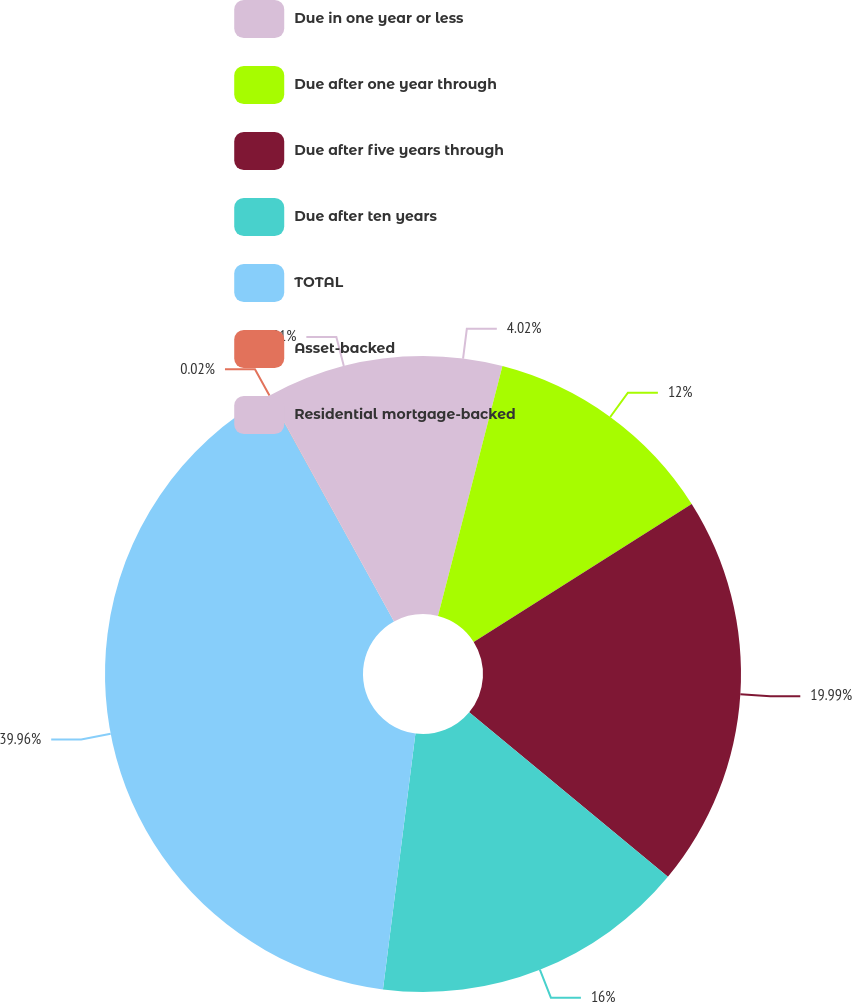Convert chart. <chart><loc_0><loc_0><loc_500><loc_500><pie_chart><fcel>Due in one year or less<fcel>Due after one year through<fcel>Due after five years through<fcel>Due after ten years<fcel>TOTAL<fcel>Asset-backed<fcel>Residential mortgage-backed<nl><fcel>4.02%<fcel>12.0%<fcel>19.99%<fcel>16.0%<fcel>39.96%<fcel>0.02%<fcel>8.01%<nl></chart> 